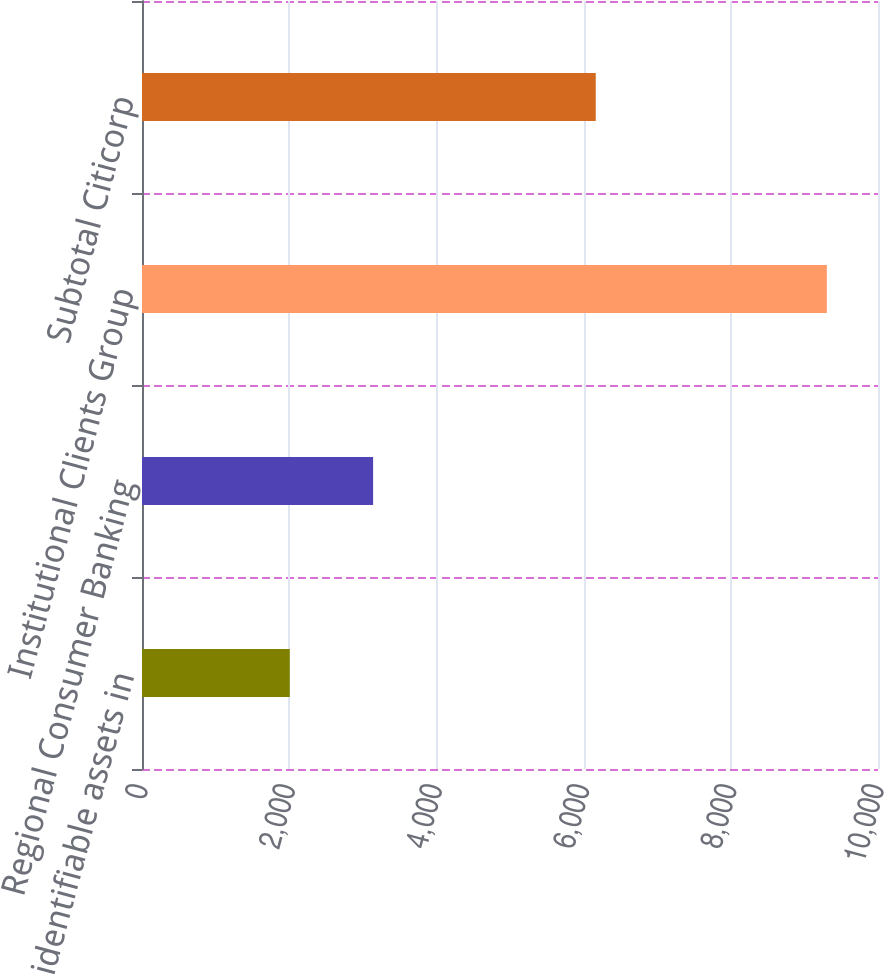<chart> <loc_0><loc_0><loc_500><loc_500><bar_chart><fcel>identifiable assets in<fcel>Regional Consumer Banking<fcel>Institutional Clients Group<fcel>Subtotal Citicorp<nl><fcel>2008<fcel>3140<fcel>9305<fcel>6165<nl></chart> 